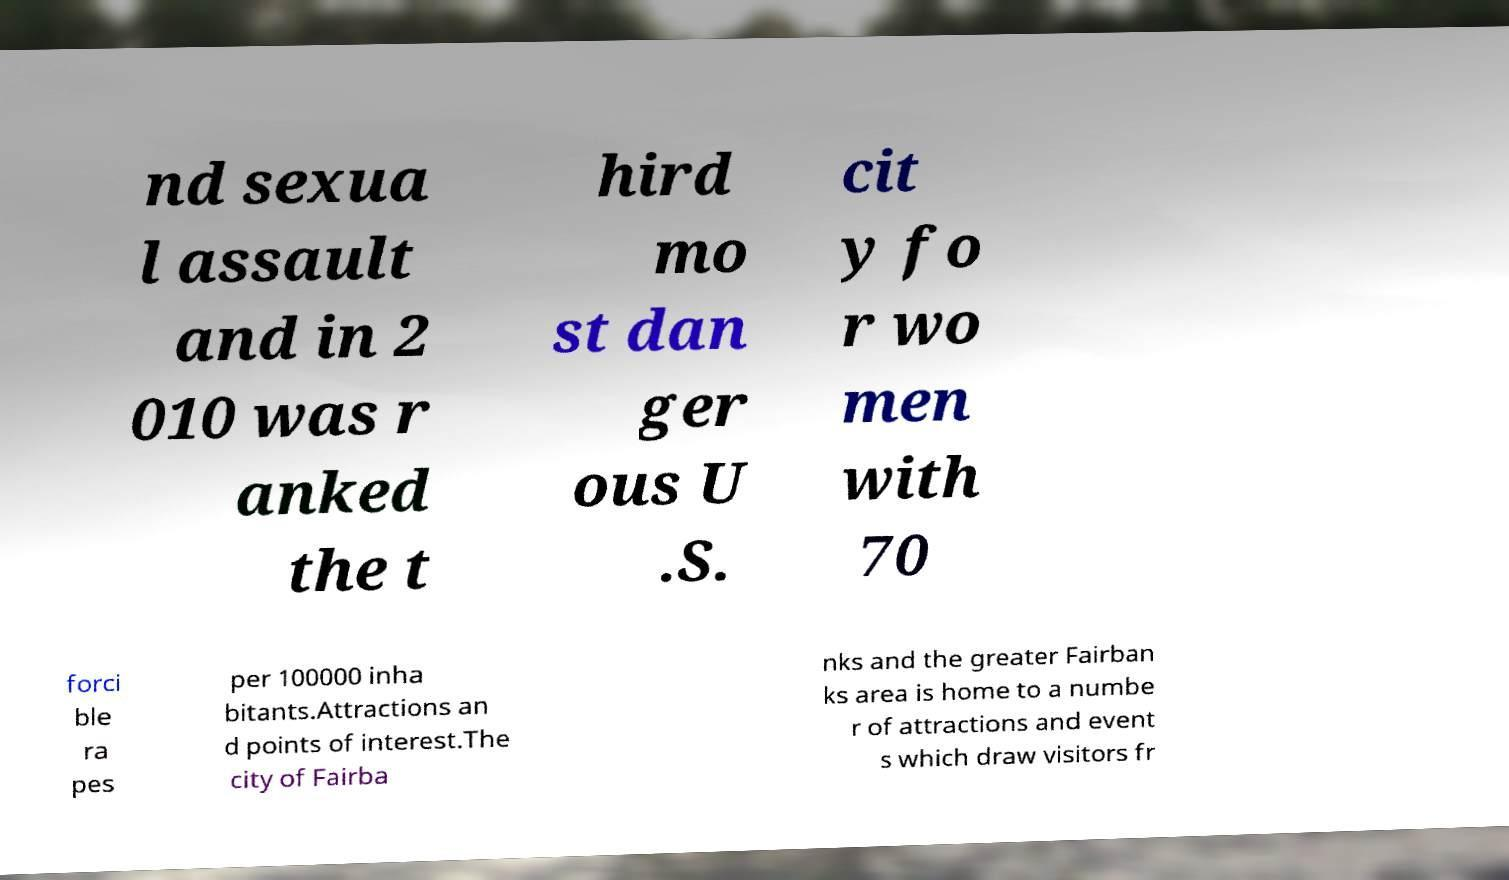Could you assist in decoding the text presented in this image and type it out clearly? nd sexua l assault and in 2 010 was r anked the t hird mo st dan ger ous U .S. cit y fo r wo men with 70 forci ble ra pes per 100000 inha bitants.Attractions an d points of interest.The city of Fairba nks and the greater Fairban ks area is home to a numbe r of attractions and event s which draw visitors fr 